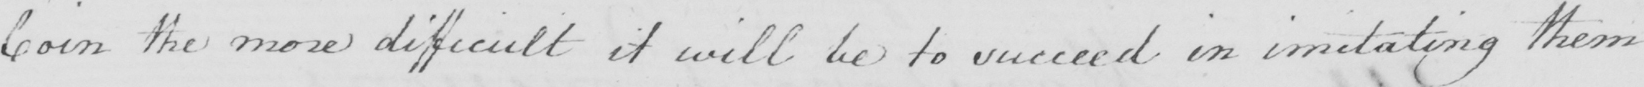Please provide the text content of this handwritten line. Coin the more difficult it will be to succeed in imitating them 